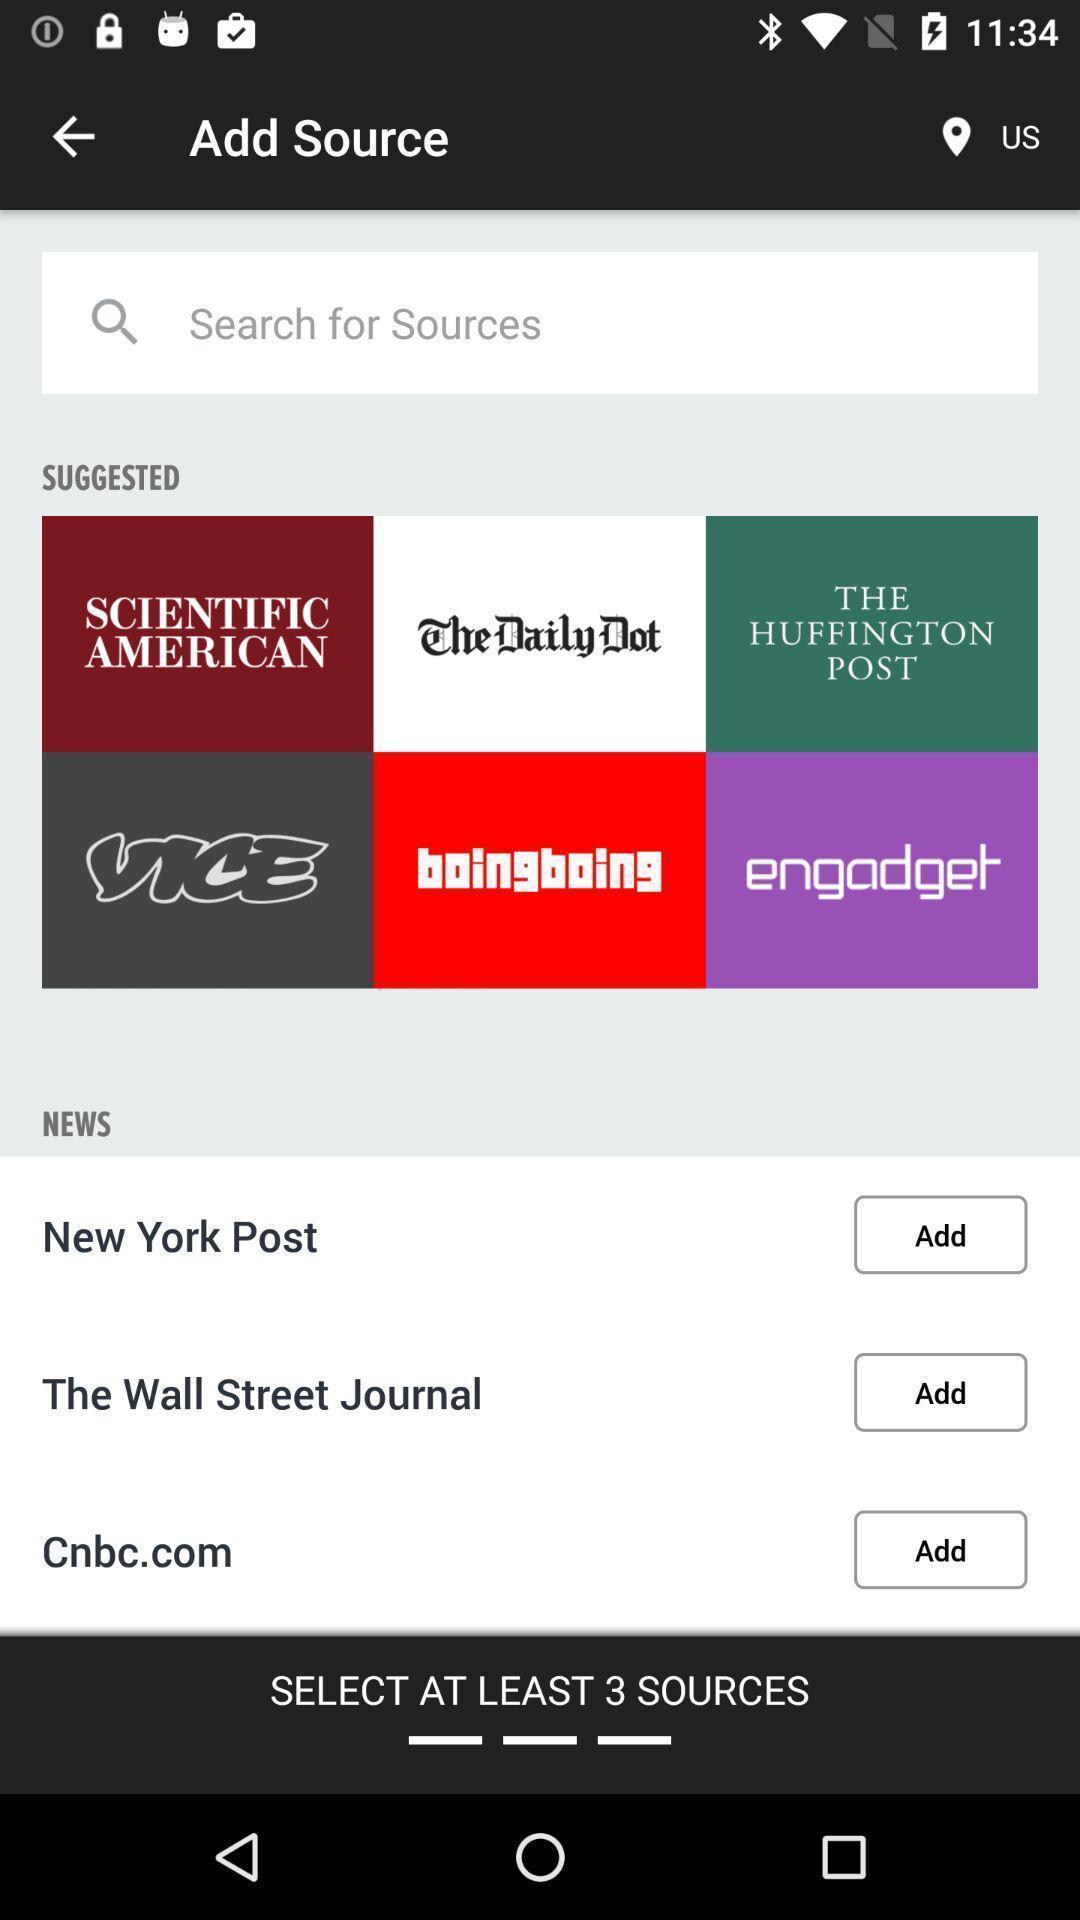Provide a description of this screenshot. Page displaying to add news post. 